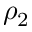<formula> <loc_0><loc_0><loc_500><loc_500>\rho _ { 2 }</formula> 